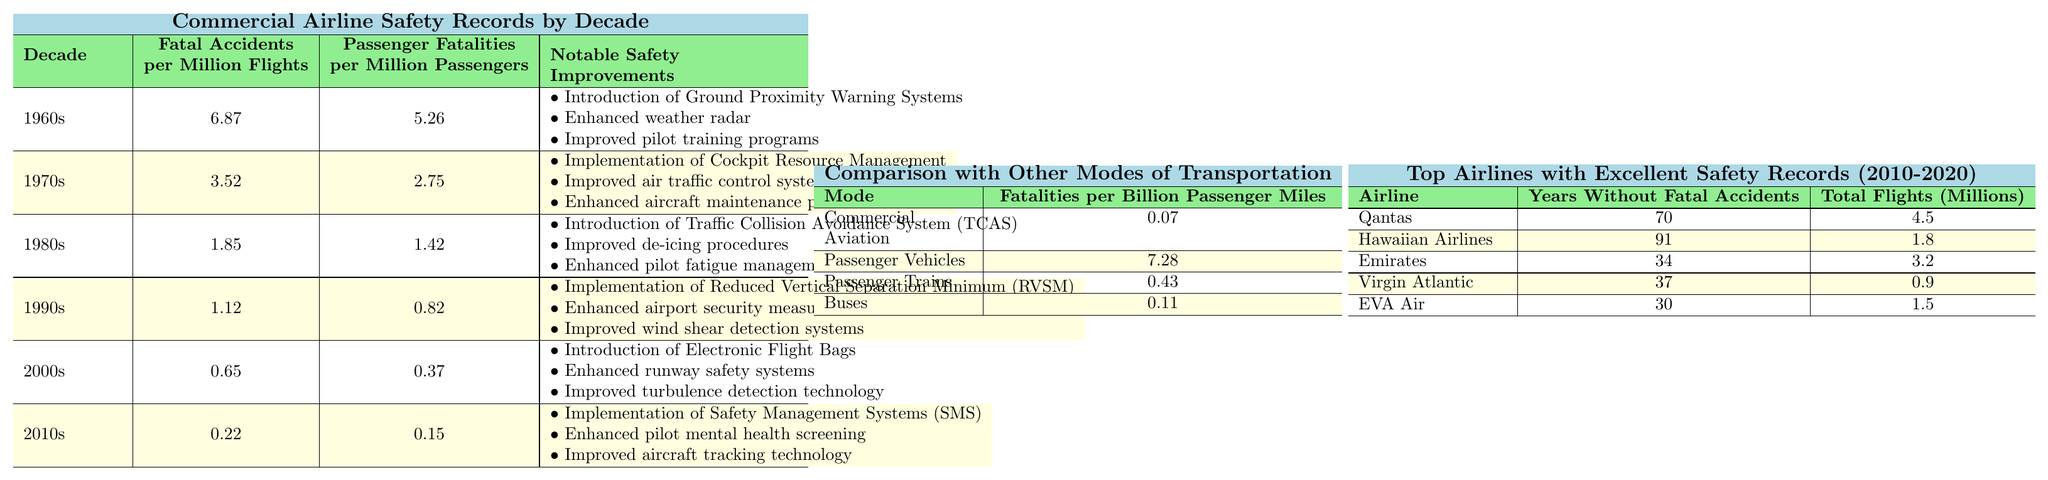What was the decade with the highest number of fatal accidents per million flights? The table shows that the 1960s had the highest fatal accidents per million flights at 6.87.
Answer: 1960s How many passenger fatalities per million passengers were recorded in the 1990s? According to the table, the 1990s had 0.82 passenger fatalities per million passengers.
Answer: 0.82 What notable safety improvement was introduced in the 1980s? The 1980s introduced the Traffic Collision Avoidance System (TCAS) among other safety improvements listed in the notable safety improvements section.
Answer: Traffic Collision Avoidance System (TCAS) Which decade showed the most significant reduction in fatal accidents per million flights compared to the previous decade? The 2000s had a fatal accidents rate of 0.65, down from 1.12 in the 1990s. The difference is 1.12 - 0.65 = 0.47, which is the largest decrease between consecutive decades.
Answer: 2000s True or False: The fatalities per billion passenger miles for commercial aviation are higher than for passenger trains. The table shows commercial aviation fatalities at 0.07 and passenger trains at 0.43, meaning commercial aviation has lower fatalities than passenger trains. Therefore, this statement is false.
Answer: False What is the average number of years without fatal accidents for the airlines listed from 2010 to 2020? To find the average, add the years without accidents for each airline (70 + 91 + 34 + 37 + 30 = 262) and divide by the number of airlines (5). Thus, the average is 262/5 = 52.4 years.
Answer: 52.4 Which decade had the least number of passenger fatalities per million passengers, and what was that figure? The 2010s had the least number of passenger fatalities per million passengers at 0.15.
Answer: 2010s: 0.15 By how much did the fatalities per billion passenger miles decrease from commercial aviation to passenger vehicles? The difference in fatalities is 7.28 - 0.07 = 7.21, indicating a significant decrease when comparing commercial aviation with passenger vehicles.
Answer: 7.21 What notable safety improvement was implemented in the 2000s? In the 2000s, electronic flight bags were one of the notable safety improvements introduced.
Answer: Electronic Flight Bags How many total flights were made by Hawaiian Airlines, and how does that compare to the total flights made by Virgin Atlantic? Hawaiian Airlines had 1.8 million flights while Virgin Atlantic had 0.9 million flights. Therefore, Hawaiian Airlines had twice as many flights as Virgin Atlantic.
Answer: Hawaiian Airlines: 1.8 million; Virgin Atlantic: 0.9 million 